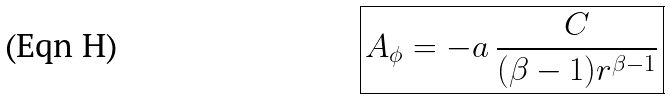Convert formula to latex. <formula><loc_0><loc_0><loc_500><loc_500>\boxed { A _ { \phi } = - a \, \frac { C } { ( \beta - 1 ) r ^ { \beta - 1 } } }</formula> 